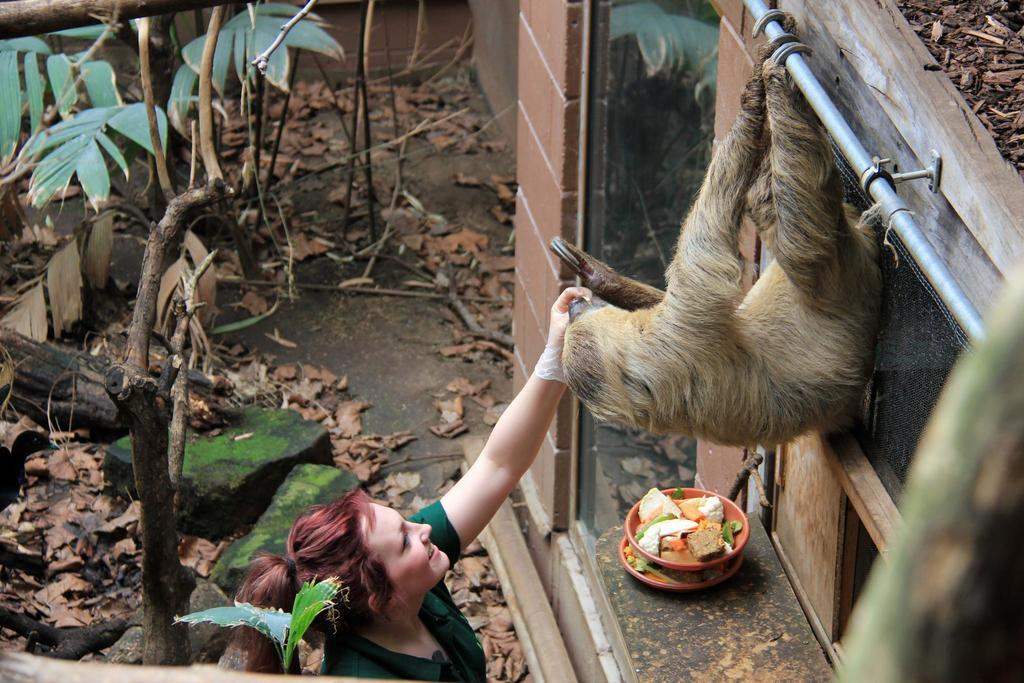What animal is present in the image? There is a monkey in the image. Who is interacting with the monkey in the image? There is a lady in the image who is feeding the monkey. What is the lady doing with the monkey? The lady is feeding the monkey. Where is the throne located in the image? There is no throne present in the image. How many snakes are wrapped around the lady's arm in the image? There are no snakes present in the image. 